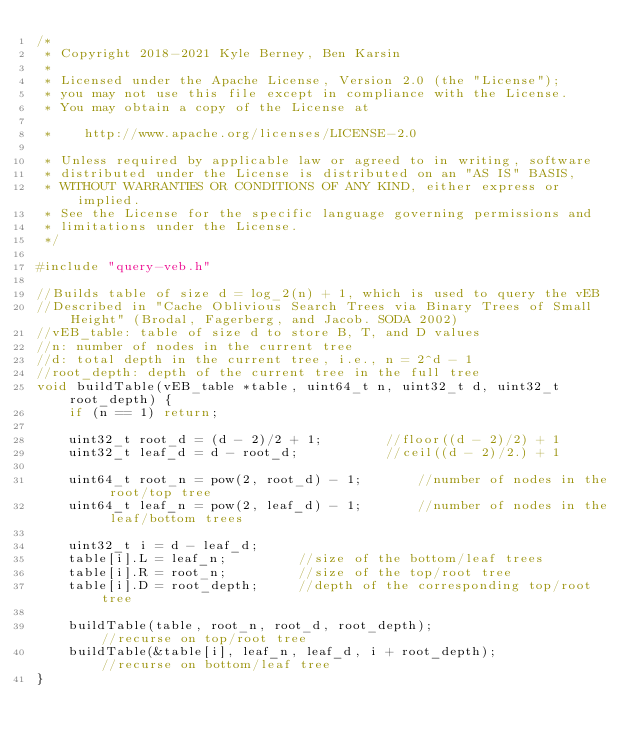Convert code to text. <code><loc_0><loc_0><loc_500><loc_500><_C++_>/*
 * Copyright 2018-2021 Kyle Berney, Ben Karsin
 *
 * Licensed under the Apache License, Version 2.0 (the "License");
 * you may not use this file except in compliance with the License.
 * You may obtain a copy of the License at

 *    http://www.apache.org/licenses/LICENSE-2.0

 * Unless required by applicable law or agreed to in writing, software
 * distributed under the License is distributed on an "AS IS" BASIS,
 * WITHOUT WARRANTIES OR CONDITIONS OF ANY KIND, either express or implied.
 * See the License for the specific language governing permissions and
 * limitations under the License.
 */

#include "query-veb.h"

//Builds table of size d = log_2(n) + 1, which is used to query the vEB
//Described in "Cache Oblivious Search Trees via Binary Trees of Small Height" (Brodal, Fagerberg, and Jacob. SODA 2002)
//vEB_table: table of size d to store B, T, and D values
//n: number of nodes in the current tree
//d: total depth in the current tree, i.e., n = 2^d - 1
//root_depth: depth of the current tree in the full tree
void buildTable(vEB_table *table, uint64_t n, uint32_t d, uint32_t root_depth) {
    if (n == 1) return;

    uint32_t root_d = (d - 2)/2 + 1;		//floor((d - 2)/2) + 1
    uint32_t leaf_d = d - root_d;			//ceil((d - 2)/2.) + 1

    uint64_t root_n = pow(2, root_d) - 1;		//number of nodes in the root/top tree
    uint64_t leaf_n = pow(2, leaf_d) - 1;       //number of nodes in the leaf/bottom trees

    uint32_t i = d - leaf_d;
    table[i].L = leaf_n;         //size of the bottom/leaf trees
    table[i].R = root_n;         //size of the top/root tree
    table[i].D = root_depth;     //depth of the corresponding top/root tree

    buildTable(table, root_n, root_d, root_depth);                      //recurse on top/root tree
    buildTable(&table[i], leaf_n, leaf_d, i + root_depth);              //recurse on bottom/leaf tree
}</code> 